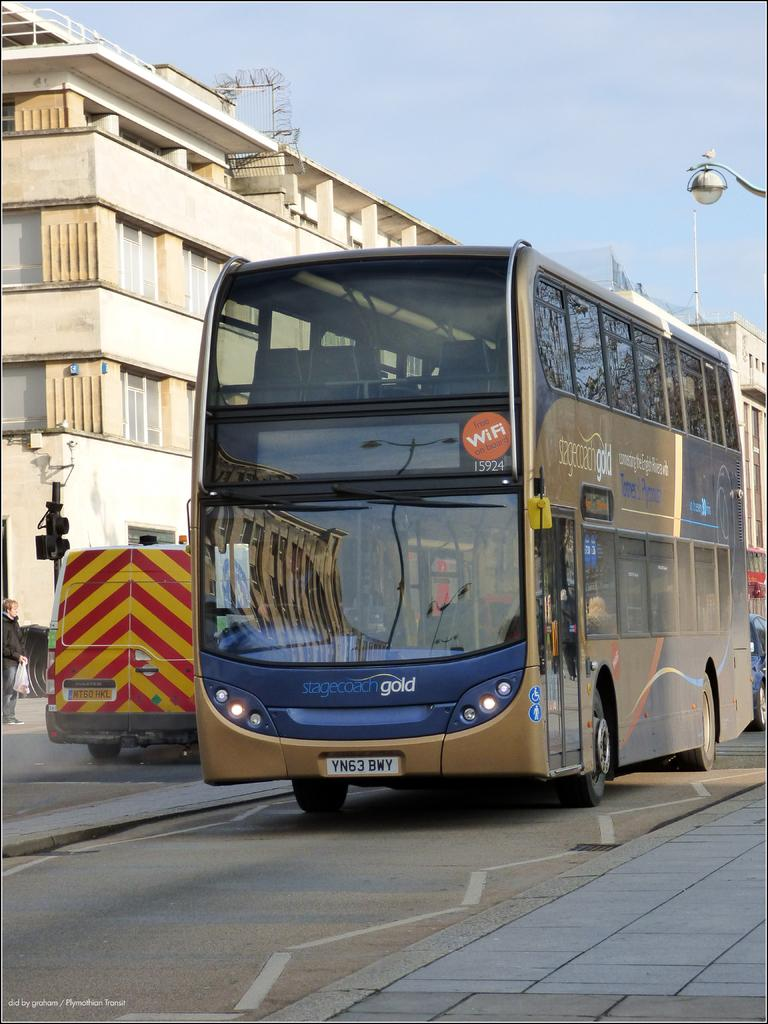What is happening on the road in the image? There are vehicles on the road in the image. Are there any people present on the road? Yes, there is a person on the road in the image. What can be seen in the background of the image? There is a traffic signal and buildings in the background of the image. What is visible in the sky in the image? The sky is visible in the background of the image. What type of station is playing the song in the image? There is no station or song present in the image; it features vehicles, a person, a traffic signal, buildings, and the sky. What action is the person performing in the image? The provided facts do not specify any action being performed by the person in the image. 